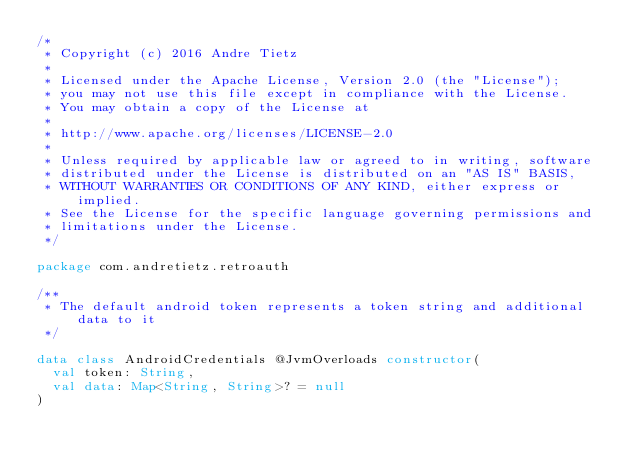<code> <loc_0><loc_0><loc_500><loc_500><_Kotlin_>/*
 * Copyright (c) 2016 Andre Tietz
 *
 * Licensed under the Apache License, Version 2.0 (the "License");
 * you may not use this file except in compliance with the License.
 * You may obtain a copy of the License at
 *
 * http://www.apache.org/licenses/LICENSE-2.0
 *
 * Unless required by applicable law or agreed to in writing, software
 * distributed under the License is distributed on an "AS IS" BASIS,
 * WITHOUT WARRANTIES OR CONDITIONS OF ANY KIND, either express or implied.
 * See the License for the specific language governing permissions and
 * limitations under the License.
 */

package com.andretietz.retroauth

/**
 * The default android token represents a token string and additional data to it
 */

data class AndroidCredentials @JvmOverloads constructor(
  val token: String,
  val data: Map<String, String>? = null
)
</code> 